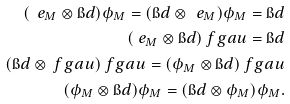<formula> <loc_0><loc_0><loc_500><loc_500>( \ e _ { M } \otimes \i d ) \phi _ { M } = ( \i d \otimes \ e _ { M } ) \phi _ { M } = \i d \\ ( \ e _ { M } \otimes \i d ) \ f g a u = \i d \\ ( \i d \otimes \ f g a u ) \ f g a u = ( \phi _ { M } \otimes \i d ) \ f g a u \\ ( \phi _ { M } \otimes \i d ) \phi _ { M } = ( \i d \otimes \phi _ { M } ) \phi _ { M } .</formula> 